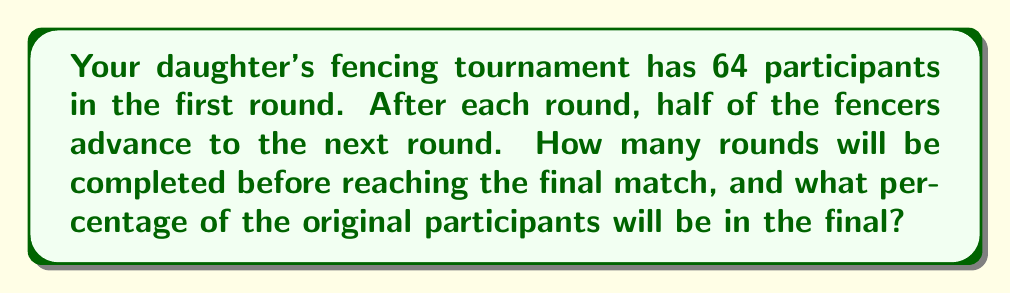Could you help me with this problem? Let's break this down step-by-step:

1) We start with 64 fencers in the first round.

2) After each round, half of the fencers advance. Let's see how this progresses:
   Round 1: 64 fencers
   Round 2: 32 fencers
   Round 3: 16 fencers
   Round 4: 8 fencers
   Round 5: 4 fencers
   Round 6: 2 fencers

3) After 6 rounds, we reach the final match with 2 fencers.

4) To calculate the percentage of original participants in the final:
   $$\text{Percentage} = \frac{\text{Number in final}}{\text{Original number}} \times 100\%$$
   $$= \frac{2}{64} \times 100\%$$
   $$= \frac{1}{32} \times 100\%$$
   $$= 3.125\%$$

5) We can also express this as a fraction: $\frac{1}{32}$ or $3\frac{1}{8}\%$
Answer: 6 rounds will be completed before reaching the final match, and $3.125\%$ (or $\frac{1}{32}$) of the original participants will be in the final. 